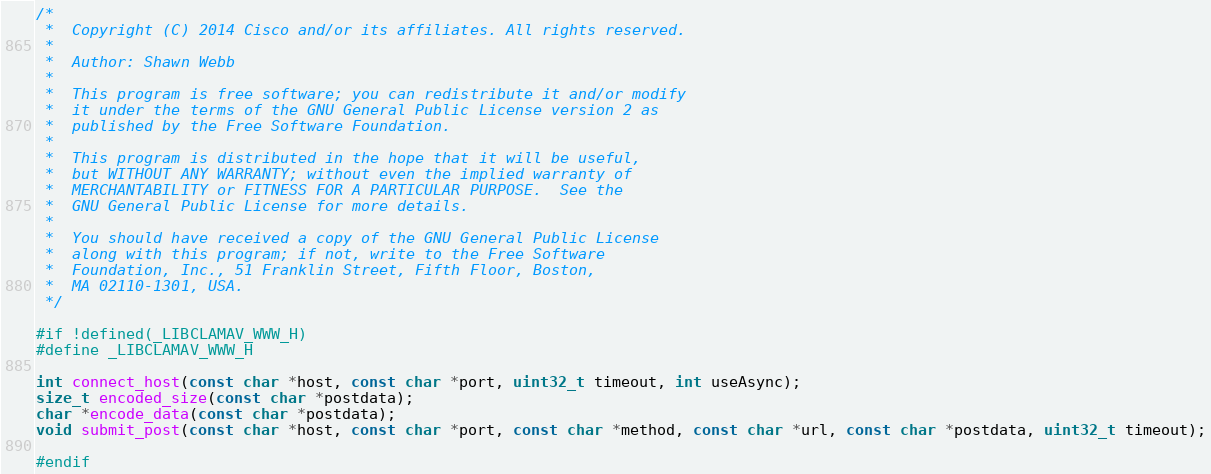<code> <loc_0><loc_0><loc_500><loc_500><_C_>/*
 *  Copyright (C) 2014 Cisco and/or its affiliates. All rights reserved.
 *
 *  Author: Shawn Webb
 *
 *  This program is free software; you can redistribute it and/or modify
 *  it under the terms of the GNU General Public License version 2 as
 *  published by the Free Software Foundation.
 *
 *  This program is distributed in the hope that it will be useful,
 *  but WITHOUT ANY WARRANTY; without even the implied warranty of
 *  MERCHANTABILITY or FITNESS FOR A PARTICULAR PURPOSE.  See the
 *  GNU General Public License for more details.
 *
 *  You should have received a copy of the GNU General Public License
 *  along with this program; if not, write to the Free Software
 *  Foundation, Inc., 51 Franklin Street, Fifth Floor, Boston,
 *  MA 02110-1301, USA.
 */

#if !defined(_LIBCLAMAV_WWW_H)
#define _LIBCLAMAV_WWW_H

int connect_host(const char *host, const char *port, uint32_t timeout, int useAsync);
size_t encoded_size(const char *postdata);
char *encode_data(const char *postdata);
void submit_post(const char *host, const char *port, const char *method, const char *url, const char *postdata, uint32_t timeout);

#endif
</code> 